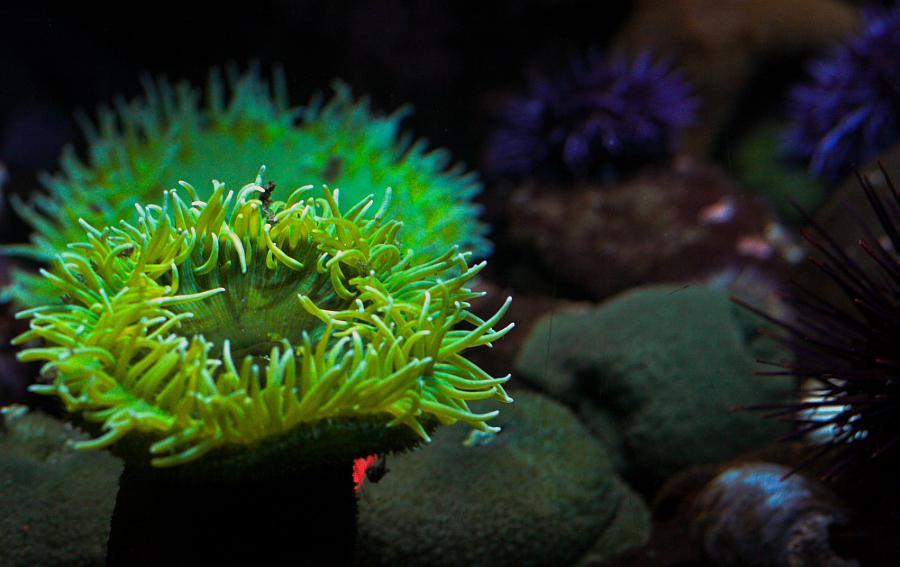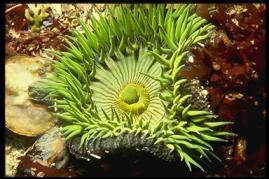The first image is the image on the left, the second image is the image on the right. Evaluate the accuracy of this statement regarding the images: "Left and right images feature one prominent neon-greenish anemone, and a center spot is visible in at least one anemone.". Is it true? Answer yes or no. Yes. The first image is the image on the left, the second image is the image on the right. Assess this claim about the two images: "There are only two Sea anemones". Correct or not? Answer yes or no. Yes. 